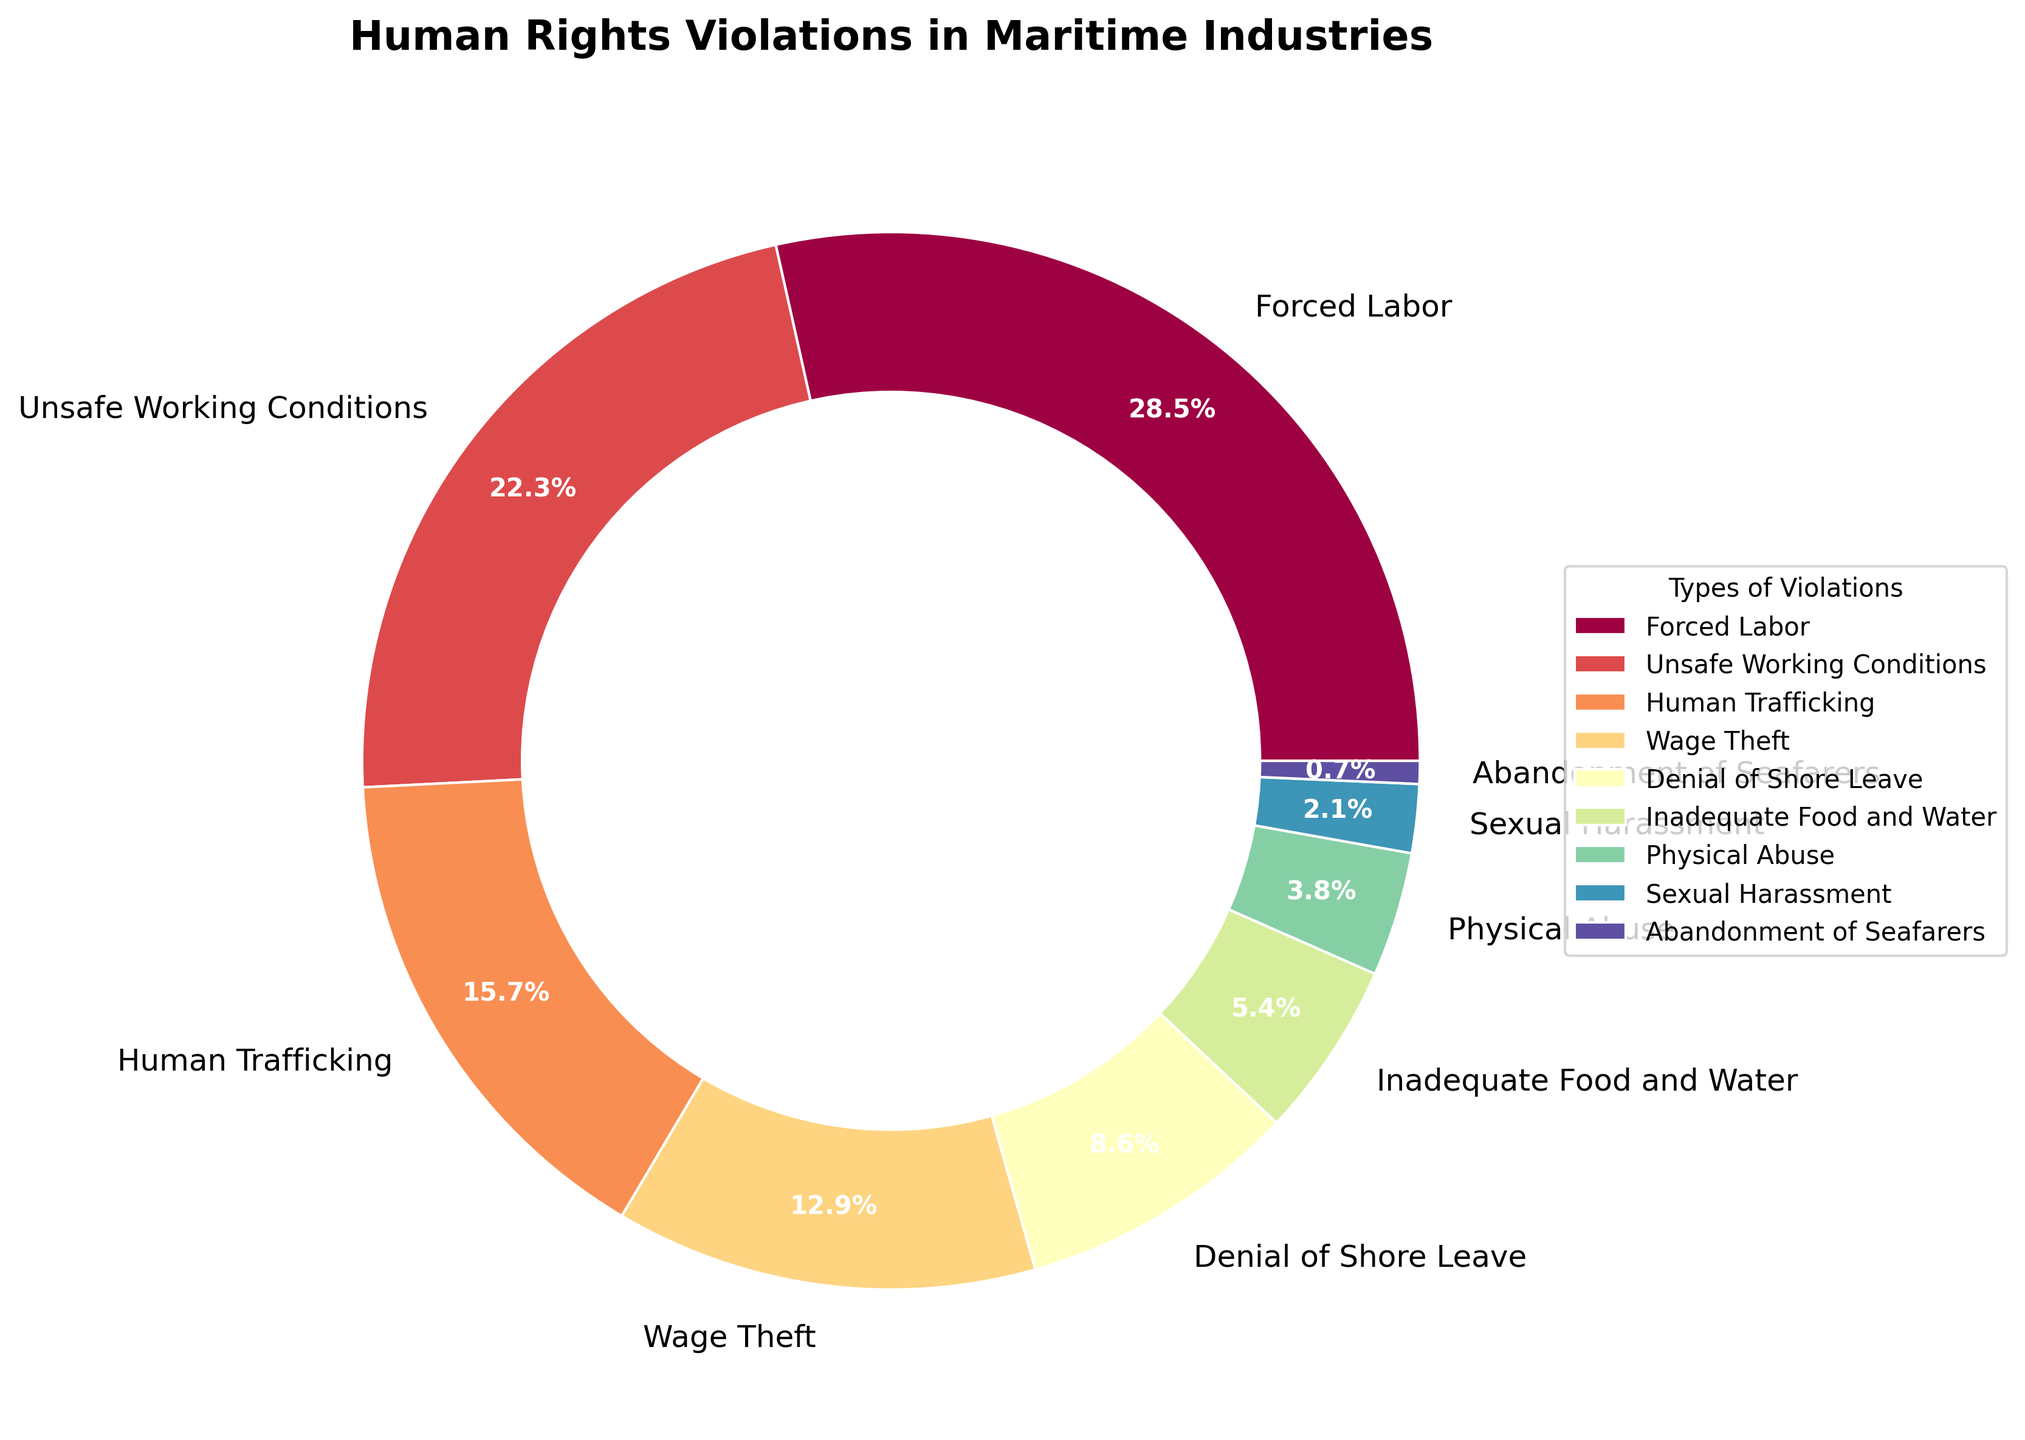What's the largest type of human rights violation in the maritime industry? The largest wedge in the pie chart is labeled "Forced Labor," and it takes up the highest percentage. This indicates that Forced Labor is the most significant type of violation.
Answer: Forced Labor What's the combined percentage of Unsafe Working Conditions and Wage Theft? Find the wedges for "Unsafe Working Conditions" and "Wage Theft," add their percentages: 22.3 + 12.9 = 35.2%.
Answer: 35.2% Which violation type has the smallest percentage? The smallest wedge in the pie chart is labeled "Abandonment of Seafarers," indicating it has the lowest percentage.
Answer: Abandonment of Seafarers Are there more instances of Human Trafficking or Denial of Shore Leave? Compare the wedges for "Human Trafficking" (15.7%) and "Denial of Shore Leave" (8.6%). Human Trafficking has a higher percentage.
Answer: Human Trafficking What's the sum of the percentages for Physical Abuse and Sexual Harassment? Find the wedges labeled "Physical Abuse" and "Sexual Harassment," add their percentages: 3.8 + 2.1 = 5.9%.
Answer: 5.9% How much higher is Forced Labor compared to Inadequate Food and Water? Deduct Inadequate Food and Water's percentage from Forced Labor's: 28.5 - 5.4 = 23.1%.
Answer: 23.1% Which two types of violations make up a total of just over 20%? Examine the wedges and find two types that add up slightly over 20%. "Unsafe Working Conditions" (22.3%) and "Denial of Shore Leave" (8.6%) together make 22.3 + 8.6 = 30.9%, too high. "Human Trafficking" (15.7%) and "Denial of Shore Leave" (8.6%) together make 15.7 + 8.6 = 24.3%, still too high. "Wage Theft" (12.9%) and "Inadequate Food and Water" (5.4%) make a combined percentage of 12.9 + 5.4 = 18.3%, too low. The pair is "Inadequate Food and Water" (5.4%) and "Physical Abuse" (3.8%) making 5.4 + 3.8 = 9.2%, still too low. To find just above 20%, check higher percentages. "Unsafe Working Conditions" (22.3%) works best. Alone, it is the closest over 20%.
Answer: Unsafe Working Conditions Alone Is Wage Theft more common than Sexual Harassment and Physical Abuse combined? Add the percentages for Physical Abuse (3.8%) and Sexual Harassment (2.1%): 3.8 + 2.1 = 5.9%. Compare 5.9% with Wage Theft’s 12.9%. Wage Theft is indeed higher.
Answer: Yes What two types form almost 55%? Look for pairs of violations that add up close to 55%. "Forced Labor" (28.5%) and "Unsafe Working Conditions" (22.3%) total 28.5 + 22.3 = 50.8%. "Forced Labor" (28.5%) and "Human Trafficking" (15.7%) total 28.5 + 15.7 = 44.2%. "Forced Labor" (28.5%) and "Wage Theft" (12.9%) total 28.5 + 12.9 = 41.4%. "Forced Labor" (28.5%) and "Denial of Shore Leave" (8.6%) total 28.5 + 8.6 = 37.1%. The closest to 55% would be "Forced Labor" (28.5%) and "Unsafe Working Conditions" (22.3%).
Answer: Forced Labor and Unsafe Working Conditions Which pie chart section has a darker color, Inadequate Food and Water or Physical Abuse? Refer to the corresponding wedges in the chart. "Inadequate Food and Water" might have a darker shade compared to "Physical Abuse" based on the pie chart colors provided from the Spectral palette.
Answer: Inadequate Food and Water 